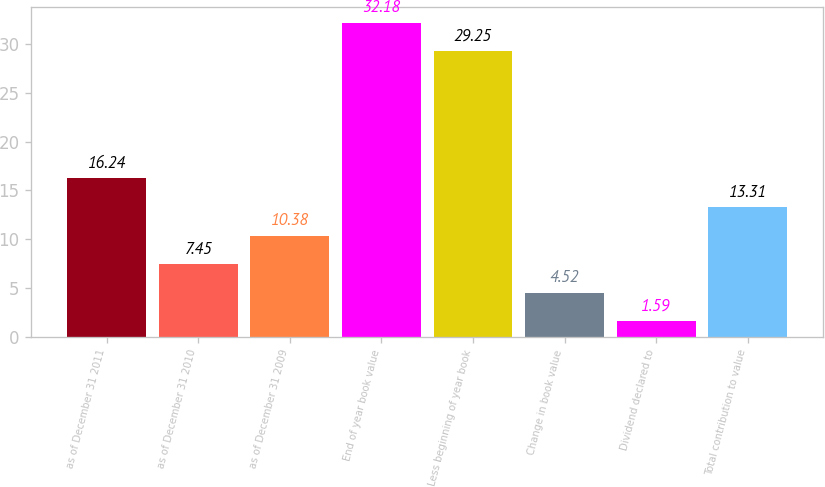<chart> <loc_0><loc_0><loc_500><loc_500><bar_chart><fcel>as of December 31 2011<fcel>as of December 31 2010<fcel>as of December 31 2009<fcel>End of year book value<fcel>Less beginning of year book<fcel>Change in book value<fcel>Dividend declared to<fcel>Total contribution to value<nl><fcel>16.24<fcel>7.45<fcel>10.38<fcel>32.18<fcel>29.25<fcel>4.52<fcel>1.59<fcel>13.31<nl></chart> 